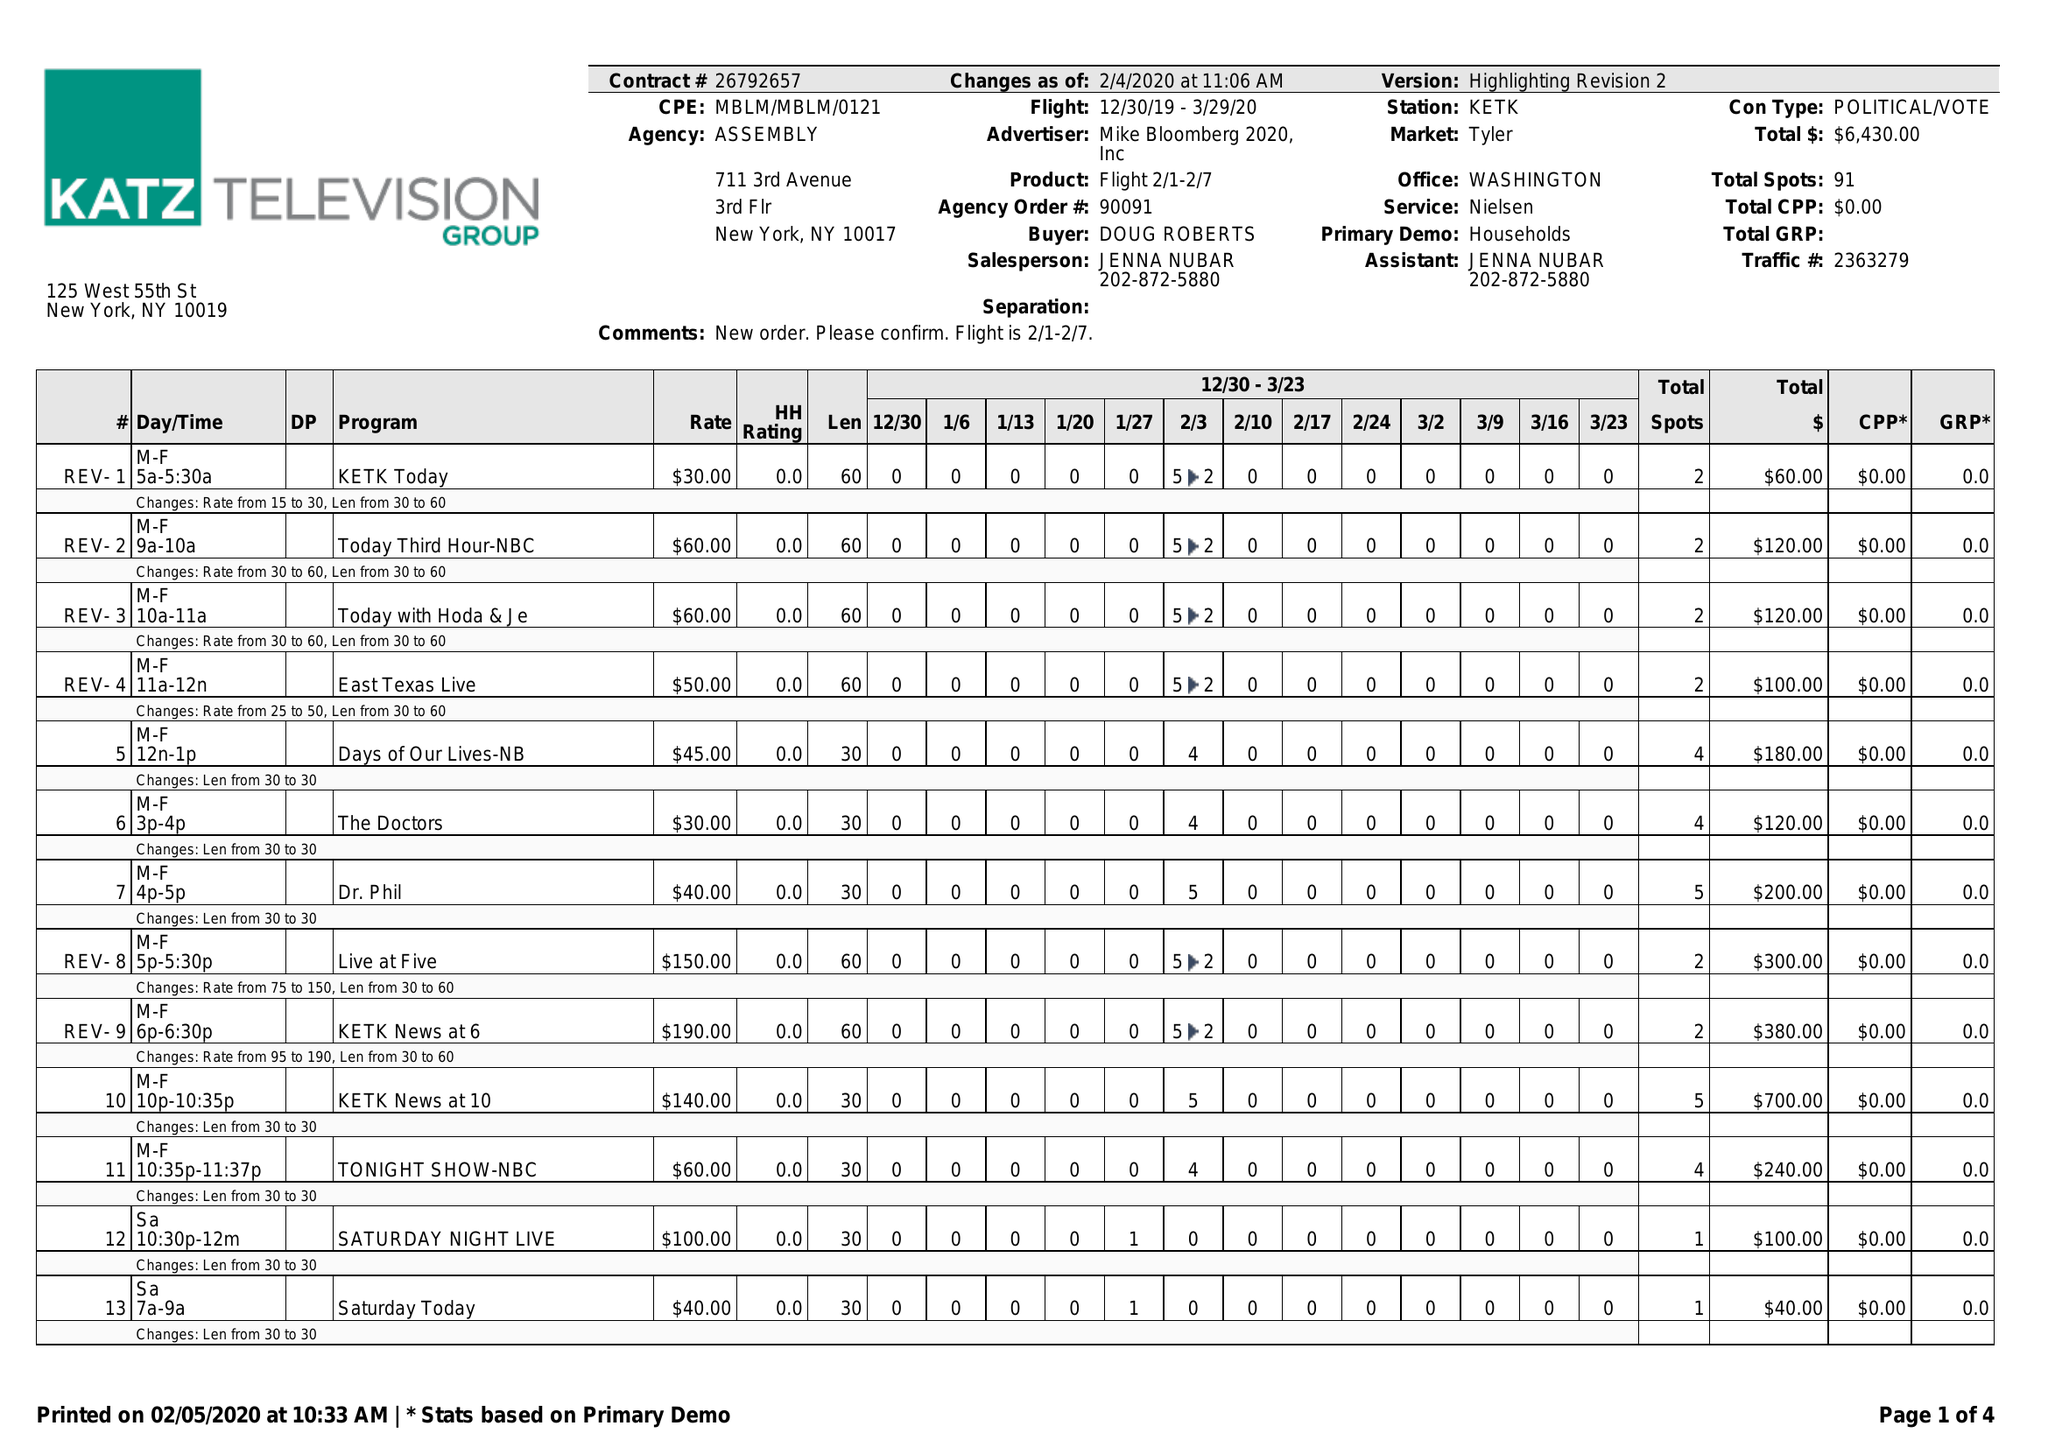What is the value for the contract_num?
Answer the question using a single word or phrase. 26792657 